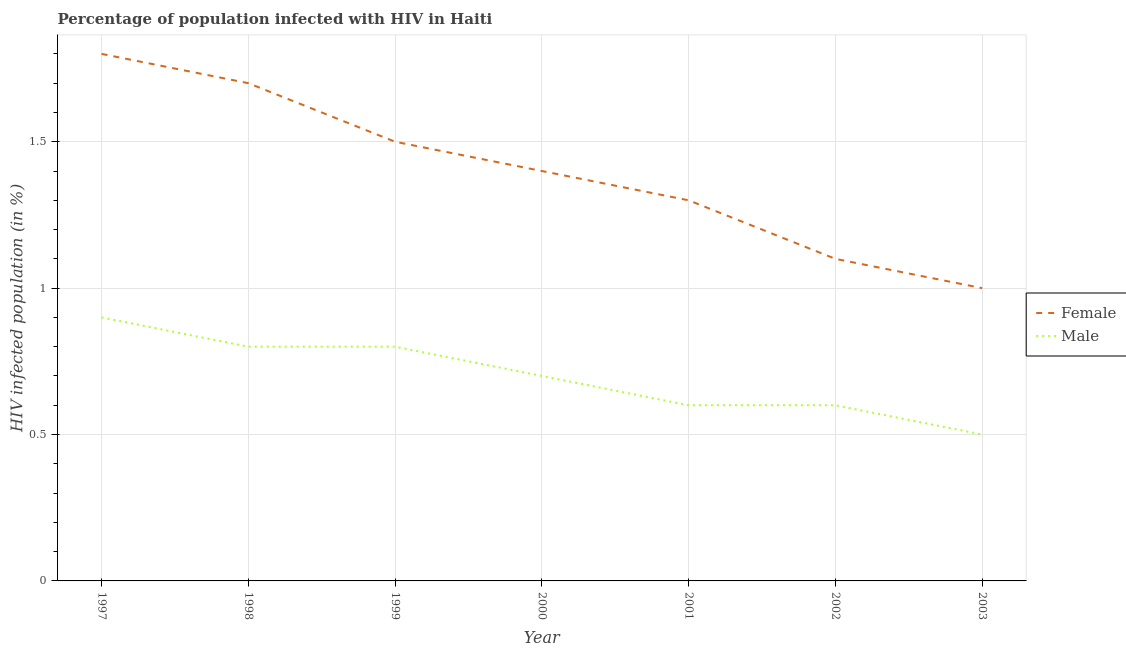How many different coloured lines are there?
Your answer should be very brief. 2. Does the line corresponding to percentage of males who are infected with hiv intersect with the line corresponding to percentage of females who are infected with hiv?
Keep it short and to the point. No. What is the total percentage of females who are infected with hiv in the graph?
Your answer should be compact. 9.8. What is the difference between the percentage of females who are infected with hiv in 2000 and that in 2001?
Offer a terse response. 0.1. What is the average percentage of females who are infected with hiv per year?
Give a very brief answer. 1.4. In how many years, is the percentage of males who are infected with hiv greater than 0.4 %?
Give a very brief answer. 7. What is the ratio of the percentage of males who are infected with hiv in 1998 to that in 2000?
Your answer should be very brief. 1.14. Is the difference between the percentage of females who are infected with hiv in 2002 and 2003 greater than the difference between the percentage of males who are infected with hiv in 2002 and 2003?
Ensure brevity in your answer.  Yes. What is the difference between the highest and the second highest percentage of females who are infected with hiv?
Offer a terse response. 0.1. In how many years, is the percentage of females who are infected with hiv greater than the average percentage of females who are infected with hiv taken over all years?
Your answer should be compact. 3. Is the sum of the percentage of males who are infected with hiv in 1999 and 2003 greater than the maximum percentage of females who are infected with hiv across all years?
Your response must be concise. No. Does the percentage of males who are infected with hiv monotonically increase over the years?
Ensure brevity in your answer.  No. Is the percentage of males who are infected with hiv strictly greater than the percentage of females who are infected with hiv over the years?
Ensure brevity in your answer.  No. How many years are there in the graph?
Offer a very short reply. 7. Does the graph contain grids?
Your response must be concise. Yes. How many legend labels are there?
Provide a short and direct response. 2. What is the title of the graph?
Give a very brief answer. Percentage of population infected with HIV in Haiti. What is the label or title of the X-axis?
Make the answer very short. Year. What is the label or title of the Y-axis?
Give a very brief answer. HIV infected population (in %). What is the HIV infected population (in %) of Male in 1997?
Ensure brevity in your answer.  0.9. What is the HIV infected population (in %) of Female in 1998?
Keep it short and to the point. 1.7. What is the HIV infected population (in %) in Male in 1998?
Provide a succinct answer. 0.8. What is the HIV infected population (in %) of Male in 1999?
Make the answer very short. 0.8. What is the HIV infected population (in %) in Male in 2000?
Your response must be concise. 0.7. What is the HIV infected population (in %) in Male in 2001?
Keep it short and to the point. 0.6. What is the HIV infected population (in %) in Female in 2002?
Keep it short and to the point. 1.1. What is the HIV infected population (in %) of Male in 2002?
Your answer should be very brief. 0.6. What is the HIV infected population (in %) of Male in 2003?
Provide a succinct answer. 0.5. Across all years, what is the maximum HIV infected population (in %) in Female?
Your response must be concise. 1.8. Across all years, what is the maximum HIV infected population (in %) of Male?
Make the answer very short. 0.9. Across all years, what is the minimum HIV infected population (in %) of Female?
Your answer should be very brief. 1. What is the total HIV infected population (in %) of Female in the graph?
Give a very brief answer. 9.8. What is the total HIV infected population (in %) in Male in the graph?
Your answer should be compact. 4.9. What is the difference between the HIV infected population (in %) in Female in 1997 and that in 1999?
Your answer should be very brief. 0.3. What is the difference between the HIV infected population (in %) of Male in 1997 and that in 1999?
Offer a very short reply. 0.1. What is the difference between the HIV infected population (in %) in Male in 1997 and that in 2001?
Keep it short and to the point. 0.3. What is the difference between the HIV infected population (in %) in Female in 1997 and that in 2002?
Offer a very short reply. 0.7. What is the difference between the HIV infected population (in %) in Male in 1997 and that in 2002?
Provide a short and direct response. 0.3. What is the difference between the HIV infected population (in %) in Male in 1997 and that in 2003?
Your answer should be very brief. 0.4. What is the difference between the HIV infected population (in %) of Male in 1998 and that in 1999?
Your answer should be very brief. 0. What is the difference between the HIV infected population (in %) of Female in 1998 and that in 2000?
Your answer should be very brief. 0.3. What is the difference between the HIV infected population (in %) in Female in 1998 and that in 2001?
Offer a terse response. 0.4. What is the difference between the HIV infected population (in %) of Female in 1999 and that in 2000?
Provide a succinct answer. 0.1. What is the difference between the HIV infected population (in %) of Male in 1999 and that in 2001?
Provide a short and direct response. 0.2. What is the difference between the HIV infected population (in %) of Female in 1999 and that in 2003?
Ensure brevity in your answer.  0.5. What is the difference between the HIV infected population (in %) of Female in 2000 and that in 2001?
Ensure brevity in your answer.  0.1. What is the difference between the HIV infected population (in %) in Female in 2000 and that in 2002?
Offer a very short reply. 0.3. What is the difference between the HIV infected population (in %) of Male in 2000 and that in 2002?
Give a very brief answer. 0.1. What is the difference between the HIV infected population (in %) of Female in 2000 and that in 2003?
Provide a short and direct response. 0.4. What is the difference between the HIV infected population (in %) of Male in 2001 and that in 2002?
Ensure brevity in your answer.  0. What is the difference between the HIV infected population (in %) of Female in 2001 and that in 2003?
Give a very brief answer. 0.3. What is the difference between the HIV infected population (in %) in Male in 2001 and that in 2003?
Provide a short and direct response. 0.1. What is the difference between the HIV infected population (in %) of Female in 2002 and that in 2003?
Offer a very short reply. 0.1. What is the difference between the HIV infected population (in %) in Female in 1997 and the HIV infected population (in %) in Male in 1999?
Offer a very short reply. 1. What is the difference between the HIV infected population (in %) in Female in 1997 and the HIV infected population (in %) in Male in 2000?
Provide a short and direct response. 1.1. What is the difference between the HIV infected population (in %) of Female in 1997 and the HIV infected population (in %) of Male in 2002?
Keep it short and to the point. 1.2. What is the difference between the HIV infected population (in %) of Female in 1997 and the HIV infected population (in %) of Male in 2003?
Offer a terse response. 1.3. What is the difference between the HIV infected population (in %) in Female in 1998 and the HIV infected population (in %) in Male in 1999?
Your answer should be very brief. 0.9. What is the difference between the HIV infected population (in %) of Female in 1998 and the HIV infected population (in %) of Male in 2000?
Keep it short and to the point. 1. What is the difference between the HIV infected population (in %) in Female in 1998 and the HIV infected population (in %) in Male in 2001?
Offer a very short reply. 1.1. What is the difference between the HIV infected population (in %) of Female in 2000 and the HIV infected population (in %) of Male in 2001?
Provide a succinct answer. 0.8. What is the difference between the HIV infected population (in %) in Female in 2001 and the HIV infected population (in %) in Male in 2002?
Make the answer very short. 0.7. What is the difference between the HIV infected population (in %) of Female in 2001 and the HIV infected population (in %) of Male in 2003?
Your answer should be compact. 0.8. What is the average HIV infected population (in %) in Female per year?
Ensure brevity in your answer.  1.4. What is the average HIV infected population (in %) in Male per year?
Your answer should be compact. 0.7. In the year 2000, what is the difference between the HIV infected population (in %) in Female and HIV infected population (in %) in Male?
Your response must be concise. 0.7. In the year 2002, what is the difference between the HIV infected population (in %) in Female and HIV infected population (in %) in Male?
Offer a very short reply. 0.5. What is the ratio of the HIV infected population (in %) in Female in 1997 to that in 1998?
Provide a succinct answer. 1.06. What is the ratio of the HIV infected population (in %) in Male in 1997 to that in 1999?
Your response must be concise. 1.12. What is the ratio of the HIV infected population (in %) in Female in 1997 to that in 2001?
Keep it short and to the point. 1.38. What is the ratio of the HIV infected population (in %) of Male in 1997 to that in 2001?
Provide a short and direct response. 1.5. What is the ratio of the HIV infected population (in %) in Female in 1997 to that in 2002?
Give a very brief answer. 1.64. What is the ratio of the HIV infected population (in %) in Female in 1997 to that in 2003?
Give a very brief answer. 1.8. What is the ratio of the HIV infected population (in %) in Female in 1998 to that in 1999?
Your answer should be very brief. 1.13. What is the ratio of the HIV infected population (in %) in Male in 1998 to that in 1999?
Provide a short and direct response. 1. What is the ratio of the HIV infected population (in %) in Female in 1998 to that in 2000?
Offer a terse response. 1.21. What is the ratio of the HIV infected population (in %) of Male in 1998 to that in 2000?
Make the answer very short. 1.14. What is the ratio of the HIV infected population (in %) of Female in 1998 to that in 2001?
Provide a short and direct response. 1.31. What is the ratio of the HIV infected population (in %) in Male in 1998 to that in 2001?
Your answer should be compact. 1.33. What is the ratio of the HIV infected population (in %) in Female in 1998 to that in 2002?
Your response must be concise. 1.55. What is the ratio of the HIV infected population (in %) of Female in 1999 to that in 2000?
Offer a terse response. 1.07. What is the ratio of the HIV infected population (in %) of Female in 1999 to that in 2001?
Your response must be concise. 1.15. What is the ratio of the HIV infected population (in %) in Male in 1999 to that in 2001?
Ensure brevity in your answer.  1.33. What is the ratio of the HIV infected population (in %) of Female in 1999 to that in 2002?
Keep it short and to the point. 1.36. What is the ratio of the HIV infected population (in %) in Female in 2000 to that in 2001?
Your response must be concise. 1.08. What is the ratio of the HIV infected population (in %) of Male in 2000 to that in 2001?
Give a very brief answer. 1.17. What is the ratio of the HIV infected population (in %) in Female in 2000 to that in 2002?
Provide a succinct answer. 1.27. What is the ratio of the HIV infected population (in %) of Female in 2000 to that in 2003?
Your answer should be compact. 1.4. What is the ratio of the HIV infected population (in %) of Male in 2000 to that in 2003?
Your response must be concise. 1.4. What is the ratio of the HIV infected population (in %) in Female in 2001 to that in 2002?
Offer a terse response. 1.18. What is the ratio of the HIV infected population (in %) of Male in 2001 to that in 2002?
Your answer should be very brief. 1. What is the ratio of the HIV infected population (in %) of Female in 2001 to that in 2003?
Your answer should be very brief. 1.3. What is the ratio of the HIV infected population (in %) in Male in 2002 to that in 2003?
Provide a succinct answer. 1.2. What is the difference between the highest and the lowest HIV infected population (in %) of Male?
Provide a succinct answer. 0.4. 